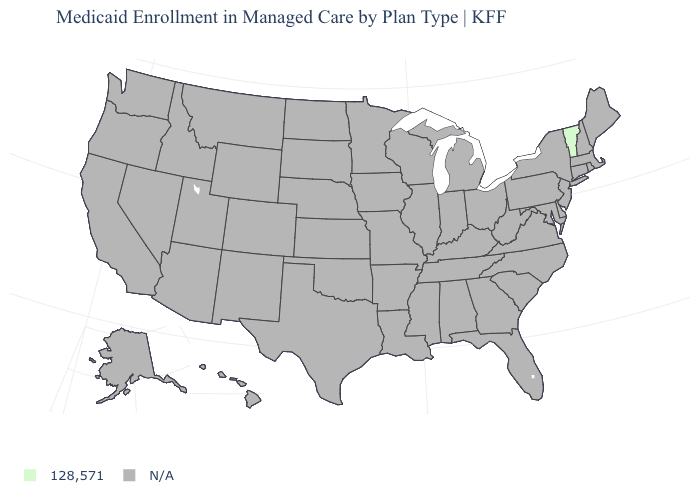What is the value of Connecticut?
Keep it brief. N/A. Name the states that have a value in the range N/A?
Write a very short answer. Alabama, Alaska, Arizona, Arkansas, California, Colorado, Connecticut, Delaware, Florida, Georgia, Hawaii, Idaho, Illinois, Indiana, Iowa, Kansas, Kentucky, Louisiana, Maine, Maryland, Massachusetts, Michigan, Minnesota, Mississippi, Missouri, Montana, Nebraska, Nevada, New Hampshire, New Jersey, New Mexico, New York, North Carolina, North Dakota, Ohio, Oklahoma, Oregon, Pennsylvania, Rhode Island, South Carolina, South Dakota, Tennessee, Texas, Utah, Virginia, Washington, West Virginia, Wisconsin, Wyoming. Does the first symbol in the legend represent the smallest category?
Be succinct. No. What is the value of Texas?
Concise answer only. N/A. What is the value of Massachusetts?
Write a very short answer. N/A. What is the value of New Hampshire?
Answer briefly. N/A. What is the lowest value in the Northeast?
Short answer required. 128,571. Name the states that have a value in the range 128,571?
Short answer required. Vermont. Which states have the highest value in the USA?
Short answer required. Vermont. Name the states that have a value in the range 128,571?
Quick response, please. Vermont. What is the value of Pennsylvania?
Be succinct. N/A. 